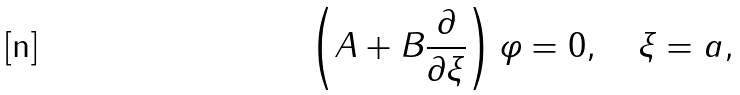<formula> <loc_0><loc_0><loc_500><loc_500>\left ( A + B \frac { \partial } { \partial \xi } \right ) \varphi = 0 , \quad \xi = a ,</formula> 